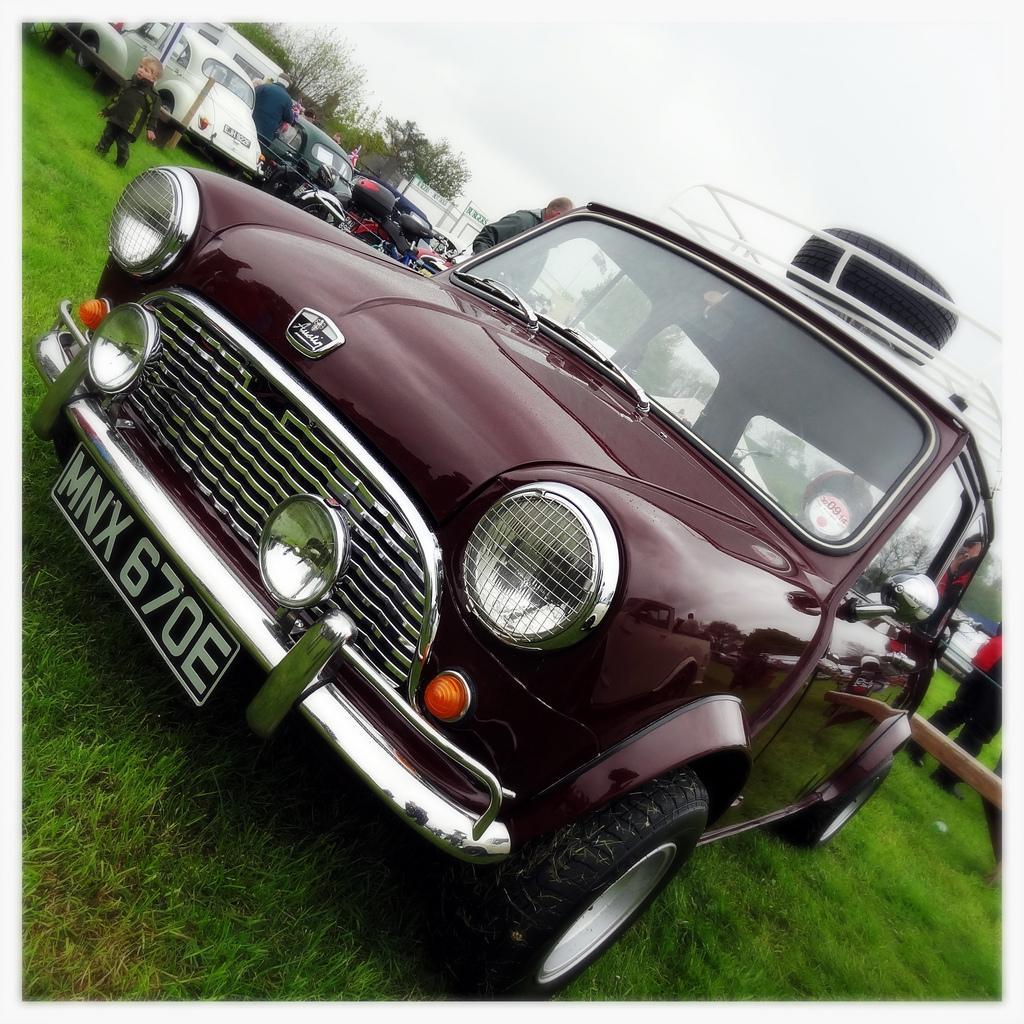Can you describe this image briefly? In this image there is the sky truncated towards the top of the image, there are trees, there is the grass truncated towards the left of the image, there is the grass truncated towards the bottom of the image, there is the grass truncated towards the right of the image, there are vehicles truncated towards the top of the image, there is an object truncated towards the right of the image, there are persons on the grass, there are persons truncated towards the right of the image, there is a car, there is a tire on the car. 